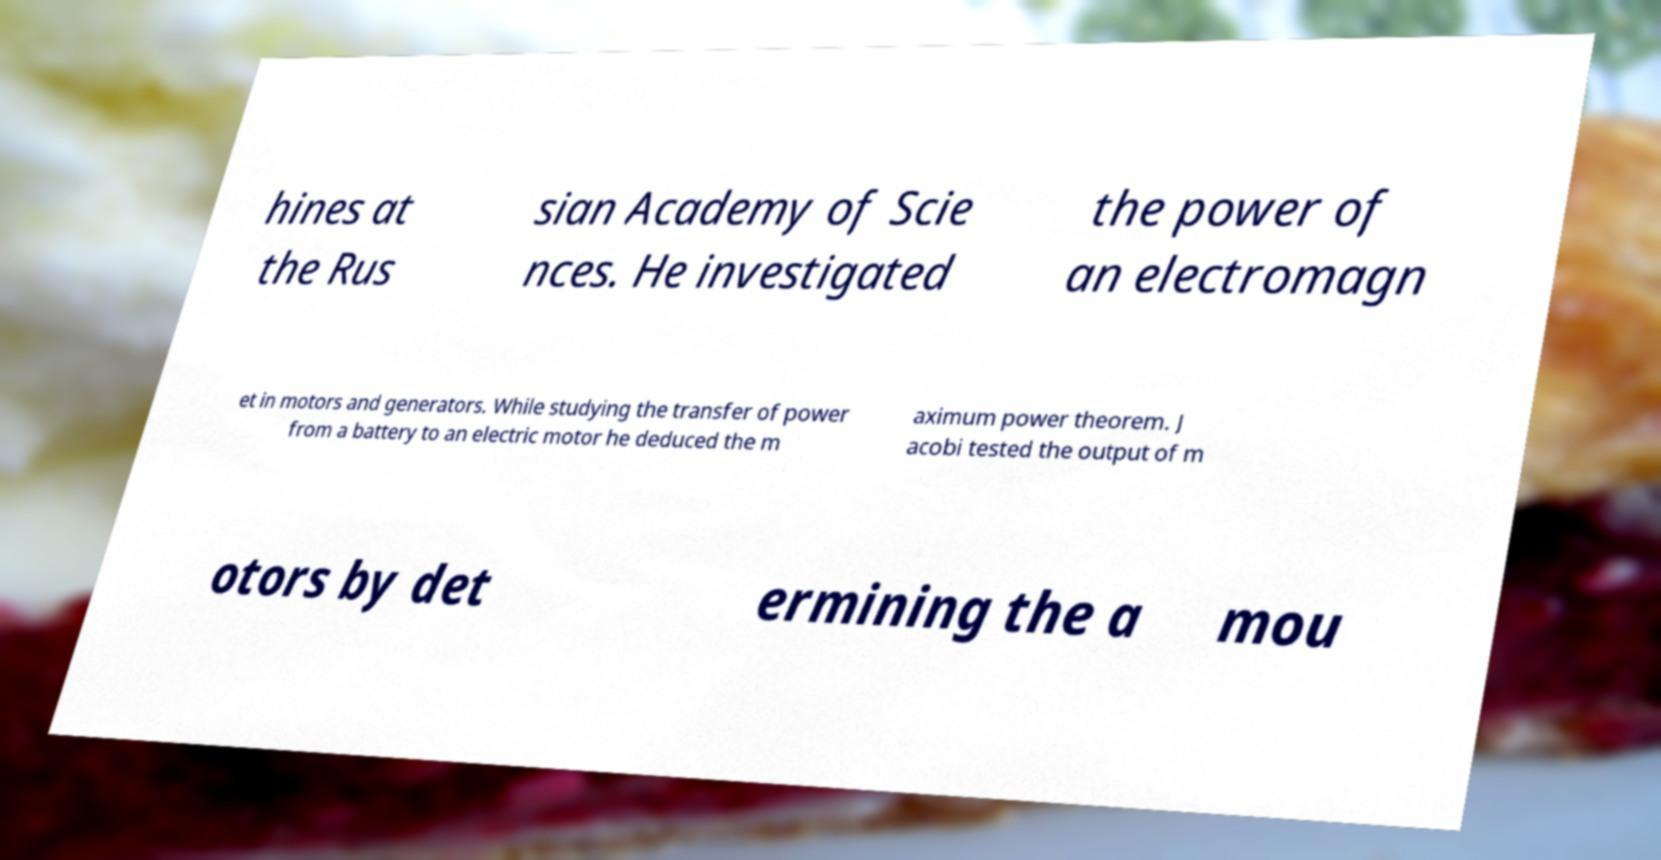Could you assist in decoding the text presented in this image and type it out clearly? hines at the Rus sian Academy of Scie nces. He investigated the power of an electromagn et in motors and generators. While studying the transfer of power from a battery to an electric motor he deduced the m aximum power theorem. J acobi tested the output of m otors by det ermining the a mou 